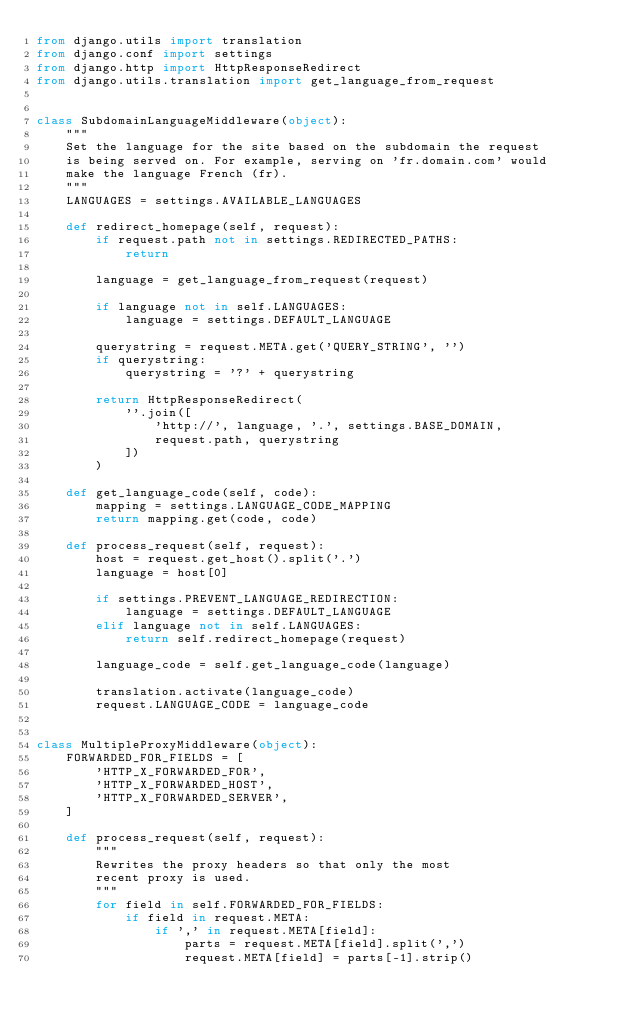<code> <loc_0><loc_0><loc_500><loc_500><_Python_>from django.utils import translation
from django.conf import settings
from django.http import HttpResponseRedirect
from django.utils.translation import get_language_from_request


class SubdomainLanguageMiddleware(object):
    """
    Set the language for the site based on the subdomain the request
    is being served on. For example, serving on 'fr.domain.com' would
    make the language French (fr).
    """
    LANGUAGES = settings.AVAILABLE_LANGUAGES

    def redirect_homepage(self, request):
        if request.path not in settings.REDIRECTED_PATHS:
            return

        language = get_language_from_request(request)

        if language not in self.LANGUAGES:
            language = settings.DEFAULT_LANGUAGE

        querystring = request.META.get('QUERY_STRING', '')
        if querystring:
            querystring = '?' + querystring

        return HttpResponseRedirect(
            ''.join([
                'http://', language, '.', settings.BASE_DOMAIN,
                request.path, querystring
            ])
        )

    def get_language_code(self, code):
        mapping = settings.LANGUAGE_CODE_MAPPING
        return mapping.get(code, code)

    def process_request(self, request):
        host = request.get_host().split('.')
        language = host[0]

        if settings.PREVENT_LANGUAGE_REDIRECTION:
            language = settings.DEFAULT_LANGUAGE
        elif language not in self.LANGUAGES:
            return self.redirect_homepage(request)

        language_code = self.get_language_code(language)

        translation.activate(language_code)
        request.LANGUAGE_CODE = language_code


class MultipleProxyMiddleware(object):
    FORWARDED_FOR_FIELDS = [
        'HTTP_X_FORWARDED_FOR',
        'HTTP_X_FORWARDED_HOST',
        'HTTP_X_FORWARDED_SERVER',
    ]

    def process_request(self, request):
        """
        Rewrites the proxy headers so that only the most
        recent proxy is used.
        """
        for field in self.FORWARDED_FOR_FIELDS:
            if field in request.META:
                if ',' in request.META[field]:
                    parts = request.META[field].split(',')
                    request.META[field] = parts[-1].strip()
</code> 